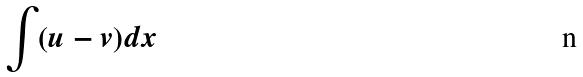<formula> <loc_0><loc_0><loc_500><loc_500>\int ( u - v ) d x</formula> 